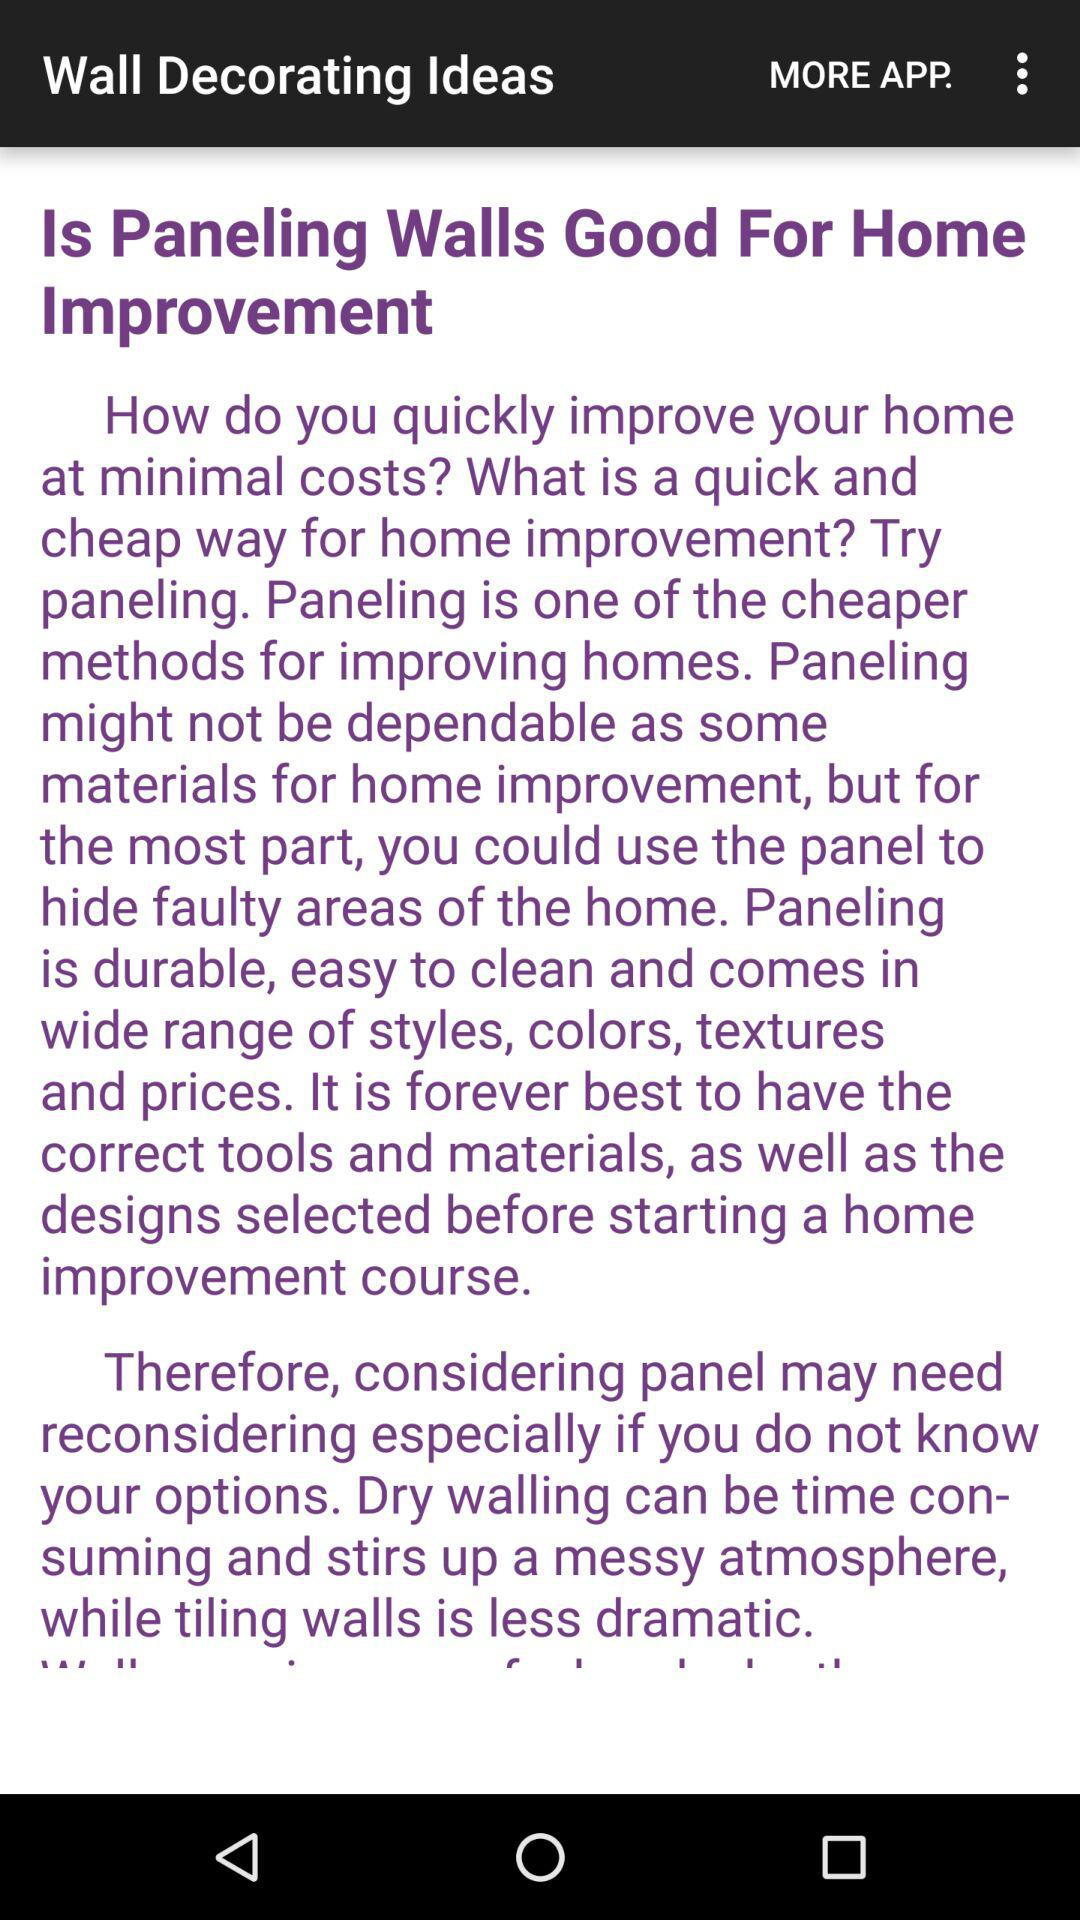What is the application name? The application name is "Wall Decorating Ideas". 